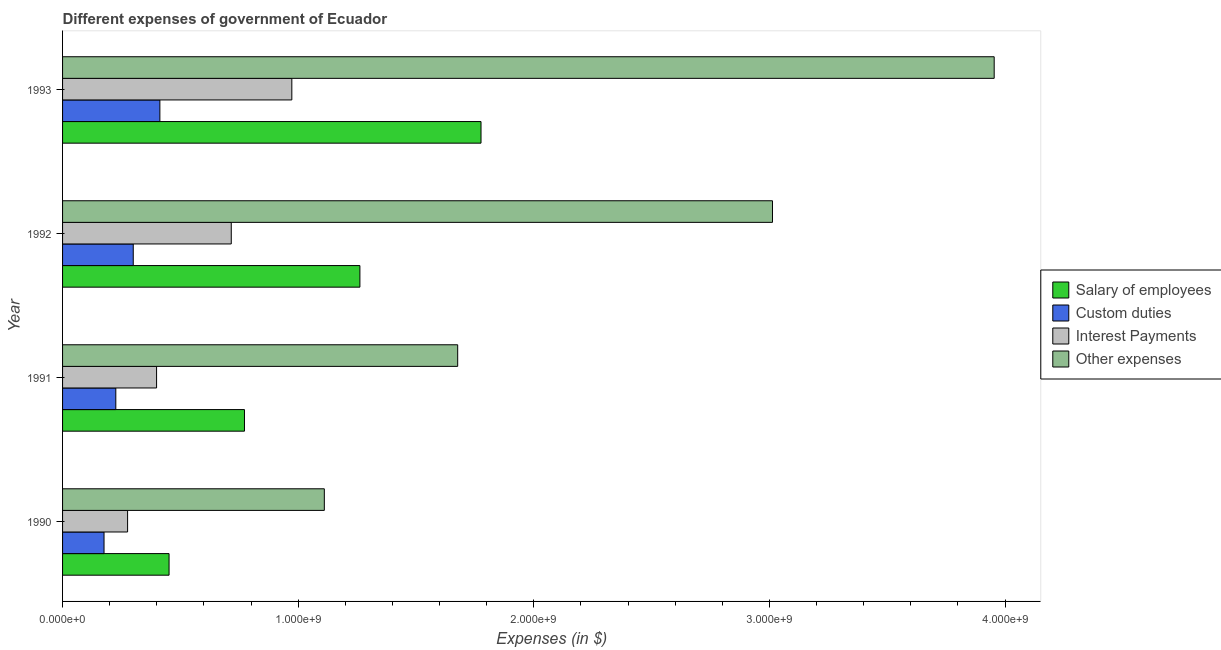How many different coloured bars are there?
Give a very brief answer. 4. How many groups of bars are there?
Your answer should be compact. 4. How many bars are there on the 4th tick from the bottom?
Your answer should be compact. 4. What is the label of the 3rd group of bars from the top?
Offer a very short reply. 1991. What is the amount spent on salary of employees in 1991?
Your answer should be compact. 7.72e+08. Across all years, what is the maximum amount spent on other expenses?
Keep it short and to the point. 3.95e+09. Across all years, what is the minimum amount spent on custom duties?
Give a very brief answer. 1.76e+08. In which year was the amount spent on other expenses maximum?
Offer a terse response. 1993. What is the total amount spent on custom duties in the graph?
Offer a terse response. 1.12e+09. What is the difference between the amount spent on interest payments in 1990 and that in 1993?
Provide a succinct answer. -6.97e+08. What is the difference between the amount spent on other expenses in 1990 and the amount spent on custom duties in 1993?
Make the answer very short. 6.98e+08. What is the average amount spent on other expenses per year?
Provide a succinct answer. 2.44e+09. In the year 1990, what is the difference between the amount spent on custom duties and amount spent on salary of employees?
Ensure brevity in your answer.  -2.76e+08. What is the ratio of the amount spent on custom duties in 1991 to that in 1992?
Offer a very short reply. 0.75. What is the difference between the highest and the second highest amount spent on salary of employees?
Offer a very short reply. 5.14e+08. What is the difference between the highest and the lowest amount spent on interest payments?
Provide a succinct answer. 6.97e+08. What does the 3rd bar from the top in 1993 represents?
Offer a terse response. Custom duties. What does the 2nd bar from the bottom in 1990 represents?
Offer a very short reply. Custom duties. Is it the case that in every year, the sum of the amount spent on salary of employees and amount spent on custom duties is greater than the amount spent on interest payments?
Your answer should be compact. Yes. What is the difference between two consecutive major ticks on the X-axis?
Make the answer very short. 1.00e+09. Where does the legend appear in the graph?
Provide a short and direct response. Center right. How many legend labels are there?
Ensure brevity in your answer.  4. What is the title of the graph?
Make the answer very short. Different expenses of government of Ecuador. Does "Other Minerals" appear as one of the legend labels in the graph?
Ensure brevity in your answer.  No. What is the label or title of the X-axis?
Offer a terse response. Expenses (in $). What is the label or title of the Y-axis?
Your response must be concise. Year. What is the Expenses (in $) in Salary of employees in 1990?
Provide a succinct answer. 4.52e+08. What is the Expenses (in $) in Custom duties in 1990?
Offer a terse response. 1.76e+08. What is the Expenses (in $) in Interest Payments in 1990?
Give a very brief answer. 2.76e+08. What is the Expenses (in $) in Other expenses in 1990?
Your response must be concise. 1.11e+09. What is the Expenses (in $) in Salary of employees in 1991?
Offer a terse response. 7.72e+08. What is the Expenses (in $) in Custom duties in 1991?
Provide a short and direct response. 2.26e+08. What is the Expenses (in $) of Interest Payments in 1991?
Keep it short and to the point. 3.99e+08. What is the Expenses (in $) in Other expenses in 1991?
Offer a very short reply. 1.68e+09. What is the Expenses (in $) in Salary of employees in 1992?
Your answer should be very brief. 1.26e+09. What is the Expenses (in $) in Custom duties in 1992?
Your response must be concise. 3.00e+08. What is the Expenses (in $) in Interest Payments in 1992?
Keep it short and to the point. 7.16e+08. What is the Expenses (in $) in Other expenses in 1992?
Your answer should be compact. 3.01e+09. What is the Expenses (in $) of Salary of employees in 1993?
Provide a succinct answer. 1.78e+09. What is the Expenses (in $) in Custom duties in 1993?
Provide a succinct answer. 4.13e+08. What is the Expenses (in $) of Interest Payments in 1993?
Keep it short and to the point. 9.73e+08. What is the Expenses (in $) of Other expenses in 1993?
Provide a short and direct response. 3.95e+09. Across all years, what is the maximum Expenses (in $) in Salary of employees?
Give a very brief answer. 1.78e+09. Across all years, what is the maximum Expenses (in $) in Custom duties?
Your response must be concise. 4.13e+08. Across all years, what is the maximum Expenses (in $) of Interest Payments?
Ensure brevity in your answer.  9.73e+08. Across all years, what is the maximum Expenses (in $) in Other expenses?
Keep it short and to the point. 3.95e+09. Across all years, what is the minimum Expenses (in $) of Salary of employees?
Make the answer very short. 4.52e+08. Across all years, what is the minimum Expenses (in $) in Custom duties?
Offer a very short reply. 1.76e+08. Across all years, what is the minimum Expenses (in $) of Interest Payments?
Provide a succinct answer. 2.76e+08. Across all years, what is the minimum Expenses (in $) of Other expenses?
Give a very brief answer. 1.11e+09. What is the total Expenses (in $) of Salary of employees in the graph?
Your answer should be compact. 4.26e+09. What is the total Expenses (in $) of Custom duties in the graph?
Make the answer very short. 1.12e+09. What is the total Expenses (in $) in Interest Payments in the graph?
Keep it short and to the point. 2.36e+09. What is the total Expenses (in $) of Other expenses in the graph?
Your response must be concise. 9.76e+09. What is the difference between the Expenses (in $) in Salary of employees in 1990 and that in 1991?
Your response must be concise. -3.20e+08. What is the difference between the Expenses (in $) of Custom duties in 1990 and that in 1991?
Ensure brevity in your answer.  -5.00e+07. What is the difference between the Expenses (in $) in Interest Payments in 1990 and that in 1991?
Your answer should be very brief. -1.23e+08. What is the difference between the Expenses (in $) in Other expenses in 1990 and that in 1991?
Offer a terse response. -5.66e+08. What is the difference between the Expenses (in $) in Salary of employees in 1990 and that in 1992?
Keep it short and to the point. -8.10e+08. What is the difference between the Expenses (in $) of Custom duties in 1990 and that in 1992?
Your answer should be compact. -1.24e+08. What is the difference between the Expenses (in $) in Interest Payments in 1990 and that in 1992?
Give a very brief answer. -4.40e+08. What is the difference between the Expenses (in $) of Other expenses in 1990 and that in 1992?
Keep it short and to the point. -1.90e+09. What is the difference between the Expenses (in $) of Salary of employees in 1990 and that in 1993?
Your answer should be compact. -1.32e+09. What is the difference between the Expenses (in $) of Custom duties in 1990 and that in 1993?
Your response must be concise. -2.37e+08. What is the difference between the Expenses (in $) of Interest Payments in 1990 and that in 1993?
Keep it short and to the point. -6.97e+08. What is the difference between the Expenses (in $) of Other expenses in 1990 and that in 1993?
Offer a very short reply. -2.84e+09. What is the difference between the Expenses (in $) of Salary of employees in 1991 and that in 1992?
Give a very brief answer. -4.90e+08. What is the difference between the Expenses (in $) of Custom duties in 1991 and that in 1992?
Your answer should be very brief. -7.40e+07. What is the difference between the Expenses (in $) in Interest Payments in 1991 and that in 1992?
Keep it short and to the point. -3.17e+08. What is the difference between the Expenses (in $) in Other expenses in 1991 and that in 1992?
Your answer should be compact. -1.34e+09. What is the difference between the Expenses (in $) in Salary of employees in 1991 and that in 1993?
Provide a short and direct response. -1.00e+09. What is the difference between the Expenses (in $) of Custom duties in 1991 and that in 1993?
Your answer should be compact. -1.87e+08. What is the difference between the Expenses (in $) in Interest Payments in 1991 and that in 1993?
Your answer should be compact. -5.74e+08. What is the difference between the Expenses (in $) of Other expenses in 1991 and that in 1993?
Ensure brevity in your answer.  -2.28e+09. What is the difference between the Expenses (in $) in Salary of employees in 1992 and that in 1993?
Your answer should be compact. -5.14e+08. What is the difference between the Expenses (in $) of Custom duties in 1992 and that in 1993?
Give a very brief answer. -1.13e+08. What is the difference between the Expenses (in $) of Interest Payments in 1992 and that in 1993?
Give a very brief answer. -2.57e+08. What is the difference between the Expenses (in $) in Other expenses in 1992 and that in 1993?
Offer a very short reply. -9.41e+08. What is the difference between the Expenses (in $) in Salary of employees in 1990 and the Expenses (in $) in Custom duties in 1991?
Give a very brief answer. 2.26e+08. What is the difference between the Expenses (in $) in Salary of employees in 1990 and the Expenses (in $) in Interest Payments in 1991?
Offer a very short reply. 5.30e+07. What is the difference between the Expenses (in $) in Salary of employees in 1990 and the Expenses (in $) in Other expenses in 1991?
Provide a short and direct response. -1.22e+09. What is the difference between the Expenses (in $) in Custom duties in 1990 and the Expenses (in $) in Interest Payments in 1991?
Give a very brief answer. -2.23e+08. What is the difference between the Expenses (in $) in Custom duties in 1990 and the Expenses (in $) in Other expenses in 1991?
Make the answer very short. -1.50e+09. What is the difference between the Expenses (in $) in Interest Payments in 1990 and the Expenses (in $) in Other expenses in 1991?
Your answer should be very brief. -1.40e+09. What is the difference between the Expenses (in $) of Salary of employees in 1990 and the Expenses (in $) of Custom duties in 1992?
Give a very brief answer. 1.52e+08. What is the difference between the Expenses (in $) in Salary of employees in 1990 and the Expenses (in $) in Interest Payments in 1992?
Make the answer very short. -2.64e+08. What is the difference between the Expenses (in $) in Salary of employees in 1990 and the Expenses (in $) in Other expenses in 1992?
Provide a succinct answer. -2.56e+09. What is the difference between the Expenses (in $) in Custom duties in 1990 and the Expenses (in $) in Interest Payments in 1992?
Make the answer very short. -5.40e+08. What is the difference between the Expenses (in $) of Custom duties in 1990 and the Expenses (in $) of Other expenses in 1992?
Keep it short and to the point. -2.84e+09. What is the difference between the Expenses (in $) of Interest Payments in 1990 and the Expenses (in $) of Other expenses in 1992?
Offer a terse response. -2.74e+09. What is the difference between the Expenses (in $) in Salary of employees in 1990 and the Expenses (in $) in Custom duties in 1993?
Offer a terse response. 3.90e+07. What is the difference between the Expenses (in $) of Salary of employees in 1990 and the Expenses (in $) of Interest Payments in 1993?
Give a very brief answer. -5.21e+08. What is the difference between the Expenses (in $) in Salary of employees in 1990 and the Expenses (in $) in Other expenses in 1993?
Give a very brief answer. -3.50e+09. What is the difference between the Expenses (in $) in Custom duties in 1990 and the Expenses (in $) in Interest Payments in 1993?
Your response must be concise. -7.97e+08. What is the difference between the Expenses (in $) of Custom duties in 1990 and the Expenses (in $) of Other expenses in 1993?
Your response must be concise. -3.78e+09. What is the difference between the Expenses (in $) in Interest Payments in 1990 and the Expenses (in $) in Other expenses in 1993?
Your response must be concise. -3.68e+09. What is the difference between the Expenses (in $) in Salary of employees in 1991 and the Expenses (in $) in Custom duties in 1992?
Keep it short and to the point. 4.72e+08. What is the difference between the Expenses (in $) in Salary of employees in 1991 and the Expenses (in $) in Interest Payments in 1992?
Your response must be concise. 5.60e+07. What is the difference between the Expenses (in $) in Salary of employees in 1991 and the Expenses (in $) in Other expenses in 1992?
Your answer should be compact. -2.24e+09. What is the difference between the Expenses (in $) of Custom duties in 1991 and the Expenses (in $) of Interest Payments in 1992?
Give a very brief answer. -4.90e+08. What is the difference between the Expenses (in $) of Custom duties in 1991 and the Expenses (in $) of Other expenses in 1992?
Ensure brevity in your answer.  -2.79e+09. What is the difference between the Expenses (in $) of Interest Payments in 1991 and the Expenses (in $) of Other expenses in 1992?
Your answer should be very brief. -2.61e+09. What is the difference between the Expenses (in $) of Salary of employees in 1991 and the Expenses (in $) of Custom duties in 1993?
Give a very brief answer. 3.59e+08. What is the difference between the Expenses (in $) of Salary of employees in 1991 and the Expenses (in $) of Interest Payments in 1993?
Offer a very short reply. -2.01e+08. What is the difference between the Expenses (in $) of Salary of employees in 1991 and the Expenses (in $) of Other expenses in 1993?
Offer a very short reply. -3.18e+09. What is the difference between the Expenses (in $) of Custom duties in 1991 and the Expenses (in $) of Interest Payments in 1993?
Make the answer very short. -7.47e+08. What is the difference between the Expenses (in $) in Custom duties in 1991 and the Expenses (in $) in Other expenses in 1993?
Ensure brevity in your answer.  -3.73e+09. What is the difference between the Expenses (in $) in Interest Payments in 1991 and the Expenses (in $) in Other expenses in 1993?
Ensure brevity in your answer.  -3.56e+09. What is the difference between the Expenses (in $) of Salary of employees in 1992 and the Expenses (in $) of Custom duties in 1993?
Offer a terse response. 8.49e+08. What is the difference between the Expenses (in $) in Salary of employees in 1992 and the Expenses (in $) in Interest Payments in 1993?
Make the answer very short. 2.89e+08. What is the difference between the Expenses (in $) of Salary of employees in 1992 and the Expenses (in $) of Other expenses in 1993?
Provide a short and direct response. -2.69e+09. What is the difference between the Expenses (in $) of Custom duties in 1992 and the Expenses (in $) of Interest Payments in 1993?
Provide a short and direct response. -6.73e+08. What is the difference between the Expenses (in $) of Custom duties in 1992 and the Expenses (in $) of Other expenses in 1993?
Make the answer very short. -3.65e+09. What is the difference between the Expenses (in $) in Interest Payments in 1992 and the Expenses (in $) in Other expenses in 1993?
Offer a terse response. -3.24e+09. What is the average Expenses (in $) in Salary of employees per year?
Your response must be concise. 1.07e+09. What is the average Expenses (in $) of Custom duties per year?
Offer a very short reply. 2.79e+08. What is the average Expenses (in $) in Interest Payments per year?
Offer a very short reply. 5.91e+08. What is the average Expenses (in $) in Other expenses per year?
Keep it short and to the point. 2.44e+09. In the year 1990, what is the difference between the Expenses (in $) of Salary of employees and Expenses (in $) of Custom duties?
Ensure brevity in your answer.  2.76e+08. In the year 1990, what is the difference between the Expenses (in $) in Salary of employees and Expenses (in $) in Interest Payments?
Keep it short and to the point. 1.76e+08. In the year 1990, what is the difference between the Expenses (in $) of Salary of employees and Expenses (in $) of Other expenses?
Your response must be concise. -6.59e+08. In the year 1990, what is the difference between the Expenses (in $) of Custom duties and Expenses (in $) of Interest Payments?
Your response must be concise. -1.00e+08. In the year 1990, what is the difference between the Expenses (in $) in Custom duties and Expenses (in $) in Other expenses?
Give a very brief answer. -9.35e+08. In the year 1990, what is the difference between the Expenses (in $) in Interest Payments and Expenses (in $) in Other expenses?
Your answer should be compact. -8.35e+08. In the year 1991, what is the difference between the Expenses (in $) in Salary of employees and Expenses (in $) in Custom duties?
Give a very brief answer. 5.46e+08. In the year 1991, what is the difference between the Expenses (in $) in Salary of employees and Expenses (in $) in Interest Payments?
Your response must be concise. 3.73e+08. In the year 1991, what is the difference between the Expenses (in $) of Salary of employees and Expenses (in $) of Other expenses?
Offer a terse response. -9.05e+08. In the year 1991, what is the difference between the Expenses (in $) in Custom duties and Expenses (in $) in Interest Payments?
Ensure brevity in your answer.  -1.73e+08. In the year 1991, what is the difference between the Expenses (in $) of Custom duties and Expenses (in $) of Other expenses?
Your answer should be compact. -1.45e+09. In the year 1991, what is the difference between the Expenses (in $) in Interest Payments and Expenses (in $) in Other expenses?
Provide a short and direct response. -1.28e+09. In the year 1992, what is the difference between the Expenses (in $) of Salary of employees and Expenses (in $) of Custom duties?
Your response must be concise. 9.62e+08. In the year 1992, what is the difference between the Expenses (in $) of Salary of employees and Expenses (in $) of Interest Payments?
Provide a short and direct response. 5.46e+08. In the year 1992, what is the difference between the Expenses (in $) in Salary of employees and Expenses (in $) in Other expenses?
Give a very brief answer. -1.75e+09. In the year 1992, what is the difference between the Expenses (in $) of Custom duties and Expenses (in $) of Interest Payments?
Offer a terse response. -4.16e+08. In the year 1992, what is the difference between the Expenses (in $) of Custom duties and Expenses (in $) of Other expenses?
Your answer should be very brief. -2.71e+09. In the year 1992, what is the difference between the Expenses (in $) of Interest Payments and Expenses (in $) of Other expenses?
Offer a terse response. -2.30e+09. In the year 1993, what is the difference between the Expenses (in $) in Salary of employees and Expenses (in $) in Custom duties?
Provide a succinct answer. 1.36e+09. In the year 1993, what is the difference between the Expenses (in $) in Salary of employees and Expenses (in $) in Interest Payments?
Your answer should be very brief. 8.03e+08. In the year 1993, what is the difference between the Expenses (in $) in Salary of employees and Expenses (in $) in Other expenses?
Give a very brief answer. -2.18e+09. In the year 1993, what is the difference between the Expenses (in $) in Custom duties and Expenses (in $) in Interest Payments?
Offer a terse response. -5.60e+08. In the year 1993, what is the difference between the Expenses (in $) of Custom duties and Expenses (in $) of Other expenses?
Offer a terse response. -3.54e+09. In the year 1993, what is the difference between the Expenses (in $) of Interest Payments and Expenses (in $) of Other expenses?
Give a very brief answer. -2.98e+09. What is the ratio of the Expenses (in $) in Salary of employees in 1990 to that in 1991?
Provide a short and direct response. 0.59. What is the ratio of the Expenses (in $) in Custom duties in 1990 to that in 1991?
Offer a terse response. 0.78. What is the ratio of the Expenses (in $) in Interest Payments in 1990 to that in 1991?
Provide a short and direct response. 0.69. What is the ratio of the Expenses (in $) of Other expenses in 1990 to that in 1991?
Your response must be concise. 0.66. What is the ratio of the Expenses (in $) in Salary of employees in 1990 to that in 1992?
Your answer should be compact. 0.36. What is the ratio of the Expenses (in $) in Custom duties in 1990 to that in 1992?
Ensure brevity in your answer.  0.59. What is the ratio of the Expenses (in $) of Interest Payments in 1990 to that in 1992?
Give a very brief answer. 0.39. What is the ratio of the Expenses (in $) of Other expenses in 1990 to that in 1992?
Keep it short and to the point. 0.37. What is the ratio of the Expenses (in $) in Salary of employees in 1990 to that in 1993?
Offer a terse response. 0.25. What is the ratio of the Expenses (in $) in Custom duties in 1990 to that in 1993?
Your answer should be compact. 0.43. What is the ratio of the Expenses (in $) of Interest Payments in 1990 to that in 1993?
Provide a short and direct response. 0.28. What is the ratio of the Expenses (in $) in Other expenses in 1990 to that in 1993?
Give a very brief answer. 0.28. What is the ratio of the Expenses (in $) of Salary of employees in 1991 to that in 1992?
Offer a very short reply. 0.61. What is the ratio of the Expenses (in $) in Custom duties in 1991 to that in 1992?
Give a very brief answer. 0.75. What is the ratio of the Expenses (in $) in Interest Payments in 1991 to that in 1992?
Your answer should be compact. 0.56. What is the ratio of the Expenses (in $) of Other expenses in 1991 to that in 1992?
Keep it short and to the point. 0.56. What is the ratio of the Expenses (in $) in Salary of employees in 1991 to that in 1993?
Give a very brief answer. 0.43. What is the ratio of the Expenses (in $) in Custom duties in 1991 to that in 1993?
Give a very brief answer. 0.55. What is the ratio of the Expenses (in $) in Interest Payments in 1991 to that in 1993?
Offer a very short reply. 0.41. What is the ratio of the Expenses (in $) of Other expenses in 1991 to that in 1993?
Your response must be concise. 0.42. What is the ratio of the Expenses (in $) of Salary of employees in 1992 to that in 1993?
Provide a short and direct response. 0.71. What is the ratio of the Expenses (in $) of Custom duties in 1992 to that in 1993?
Your answer should be very brief. 0.73. What is the ratio of the Expenses (in $) of Interest Payments in 1992 to that in 1993?
Your response must be concise. 0.74. What is the ratio of the Expenses (in $) in Other expenses in 1992 to that in 1993?
Offer a very short reply. 0.76. What is the difference between the highest and the second highest Expenses (in $) of Salary of employees?
Your response must be concise. 5.14e+08. What is the difference between the highest and the second highest Expenses (in $) in Custom duties?
Your answer should be very brief. 1.13e+08. What is the difference between the highest and the second highest Expenses (in $) of Interest Payments?
Your answer should be compact. 2.57e+08. What is the difference between the highest and the second highest Expenses (in $) of Other expenses?
Your answer should be very brief. 9.41e+08. What is the difference between the highest and the lowest Expenses (in $) in Salary of employees?
Your answer should be compact. 1.32e+09. What is the difference between the highest and the lowest Expenses (in $) of Custom duties?
Your response must be concise. 2.37e+08. What is the difference between the highest and the lowest Expenses (in $) of Interest Payments?
Your answer should be compact. 6.97e+08. What is the difference between the highest and the lowest Expenses (in $) in Other expenses?
Keep it short and to the point. 2.84e+09. 